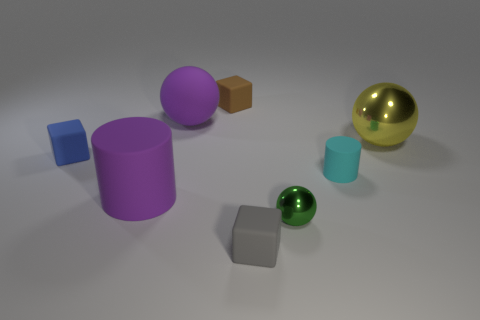There is a big object that is both left of the gray rubber thing and behind the big purple cylinder; what is its shape? The object that meets your description is a sphere. It's positioned to the left of the gray cube (which you referred to as a 'rubber thing') and directly behind the large purple cylinder. 